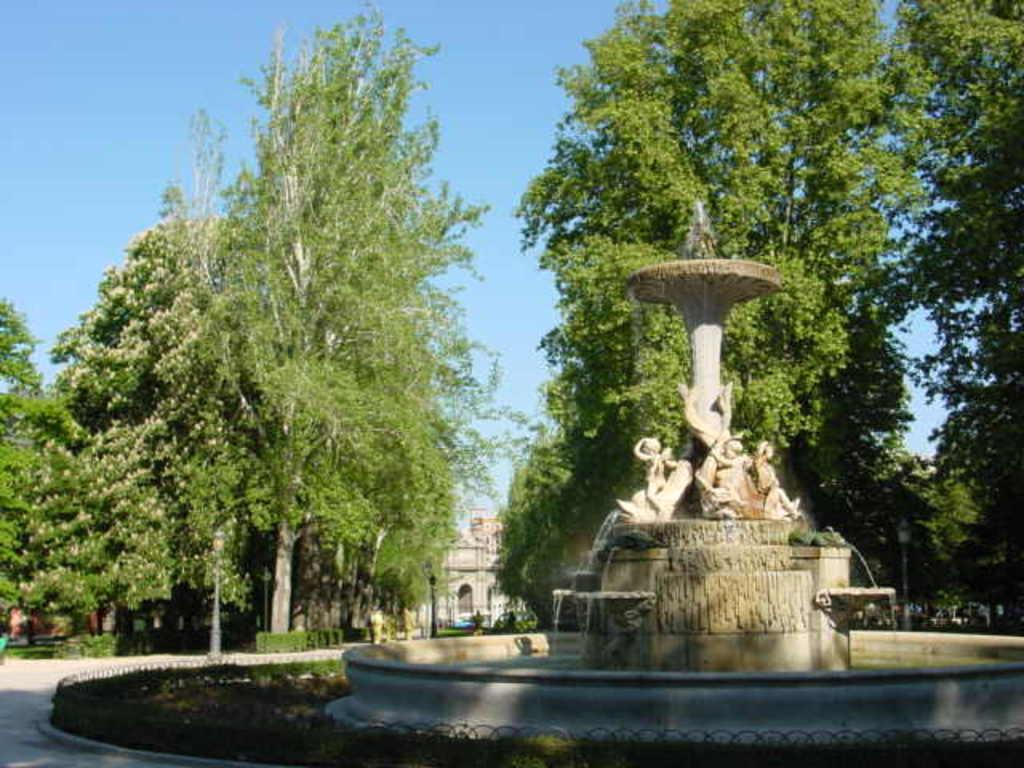What is the main feature in the image? There is a sculpture fountain in the image. What other elements can be seen in the image? There are plants, trees, poles, lights, and a building visible in the image. What is the background of the image? The sky is visible in the background of the image. How many pigs are present in the image? There are no pigs present in the image. What country is the visitor from in the image? There is no visitor mentioned or depicted in the image. 